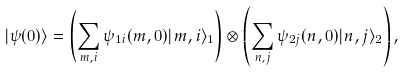<formula> <loc_0><loc_0><loc_500><loc_500>| \psi ( 0 ) \rangle = \left ( \sum _ { m , i } \psi _ { 1 i } ( m , 0 ) | m , i \rangle _ { 1 } \right ) \otimes \left ( \sum _ { n , j } \psi _ { 2 j } ( n , 0 ) | n , j \rangle _ { 2 } \right ) ,</formula> 